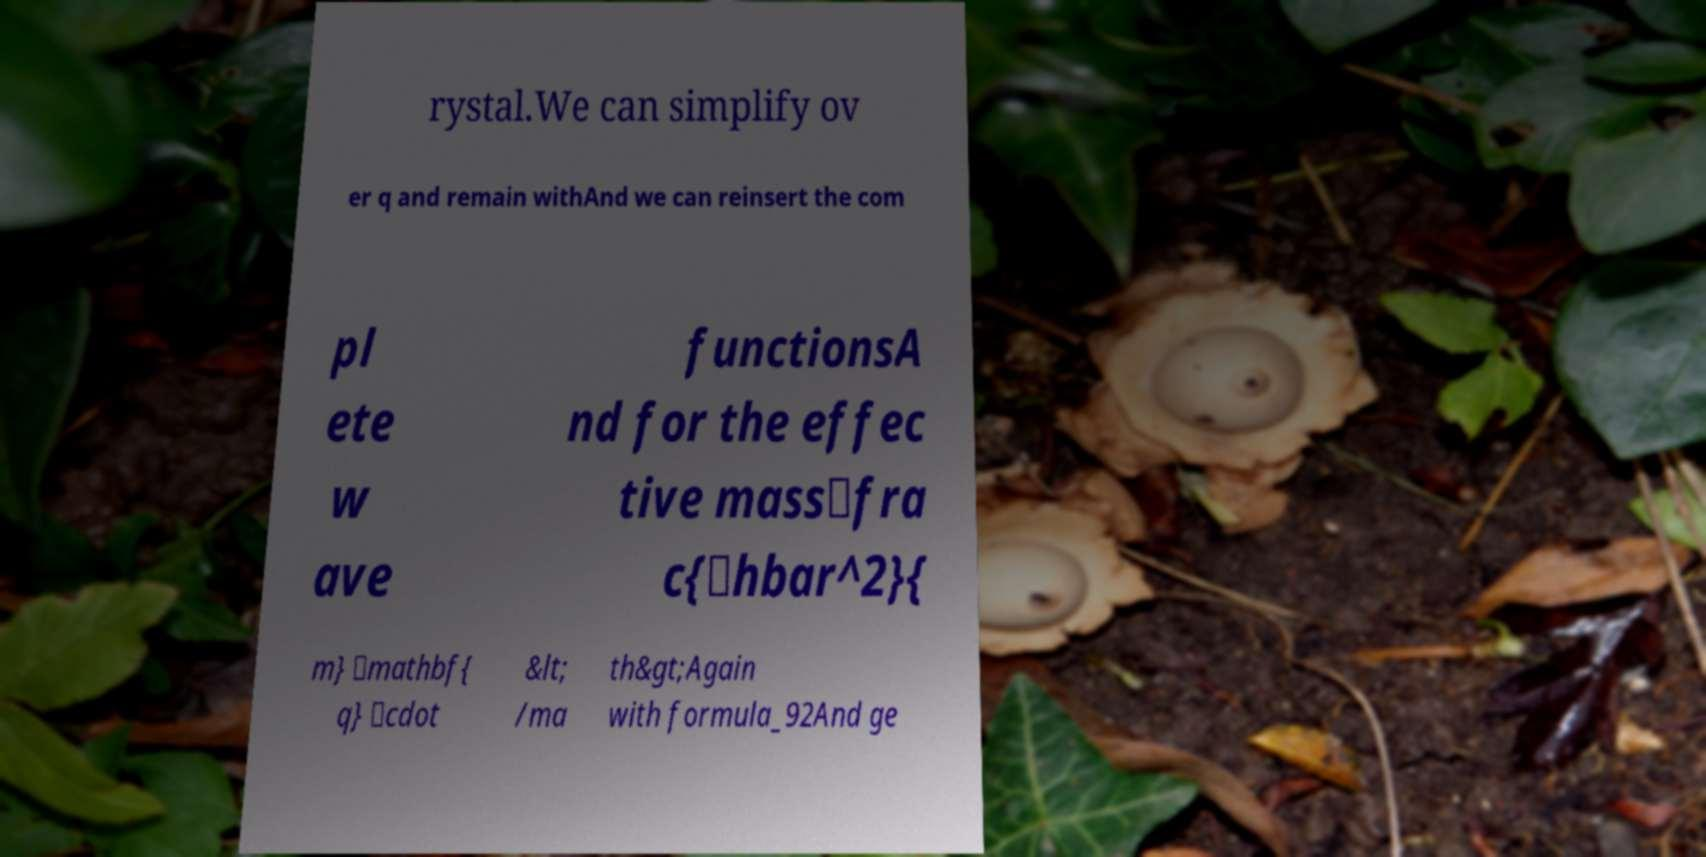Please identify and transcribe the text found in this image. rystal.We can simplify ov er q and remain withAnd we can reinsert the com pl ete w ave functionsA nd for the effec tive mass\fra c{\hbar^2}{ m} \mathbf{ q} \cdot &lt; /ma th&gt;Again with formula_92And ge 